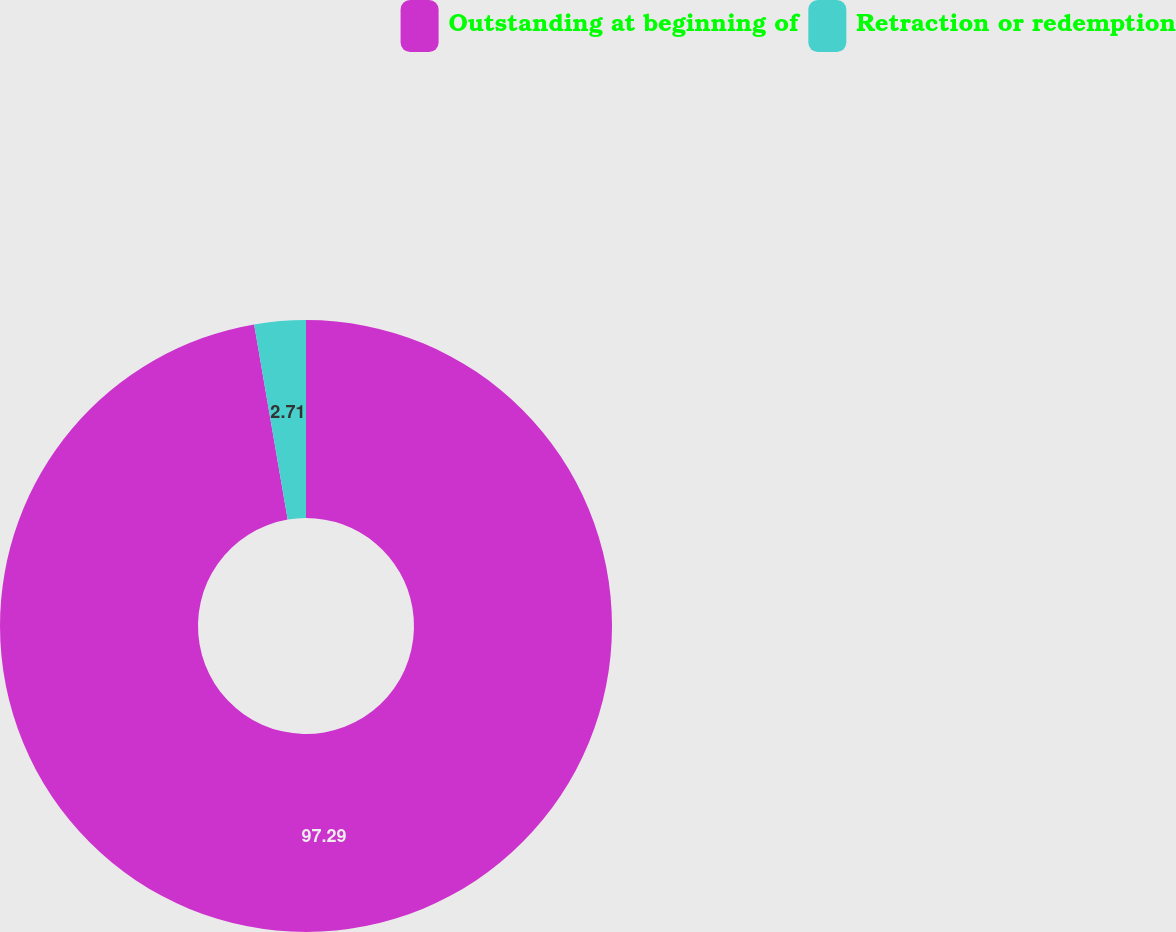Convert chart. <chart><loc_0><loc_0><loc_500><loc_500><pie_chart><fcel>Outstanding at beginning of<fcel>Retraction or redemption<nl><fcel>97.29%<fcel>2.71%<nl></chart> 